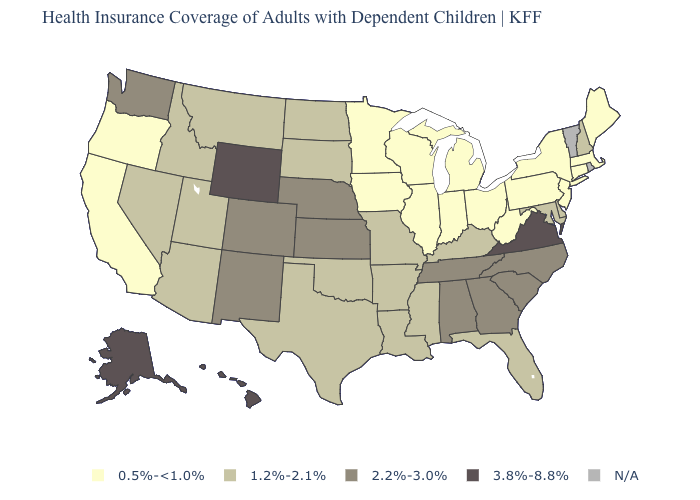Among the states that border Florida , which have the lowest value?
Concise answer only. Alabama, Georgia. What is the value of New Hampshire?
Concise answer only. 1.2%-2.1%. Which states have the lowest value in the USA?
Give a very brief answer. California, Connecticut, Illinois, Indiana, Iowa, Maine, Massachusetts, Michigan, Minnesota, New Jersey, New York, Ohio, Oregon, Pennsylvania, West Virginia, Wisconsin. What is the highest value in the USA?
Keep it brief. 3.8%-8.8%. What is the value of Maine?
Give a very brief answer. 0.5%-<1.0%. Does North Dakota have the lowest value in the USA?
Be succinct. No. What is the value of Illinois?
Quick response, please. 0.5%-<1.0%. Does Wyoming have the highest value in the West?
Give a very brief answer. Yes. What is the highest value in the West ?
Concise answer only. 3.8%-8.8%. What is the value of Delaware?
Be succinct. 1.2%-2.1%. Name the states that have a value in the range 3.8%-8.8%?
Concise answer only. Alaska, Hawaii, Virginia, Wyoming. Name the states that have a value in the range 2.2%-3.0%?
Keep it brief. Alabama, Colorado, Georgia, Kansas, Nebraska, New Mexico, North Carolina, South Carolina, Tennessee, Washington. Name the states that have a value in the range 3.8%-8.8%?
Keep it brief. Alaska, Hawaii, Virginia, Wyoming. What is the value of New Hampshire?
Concise answer only. 1.2%-2.1%. What is the value of Delaware?
Give a very brief answer. 1.2%-2.1%. 